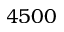Convert formula to latex. <formula><loc_0><loc_0><loc_500><loc_500>4 5 0 0</formula> 